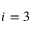<formula> <loc_0><loc_0><loc_500><loc_500>i = 3</formula> 